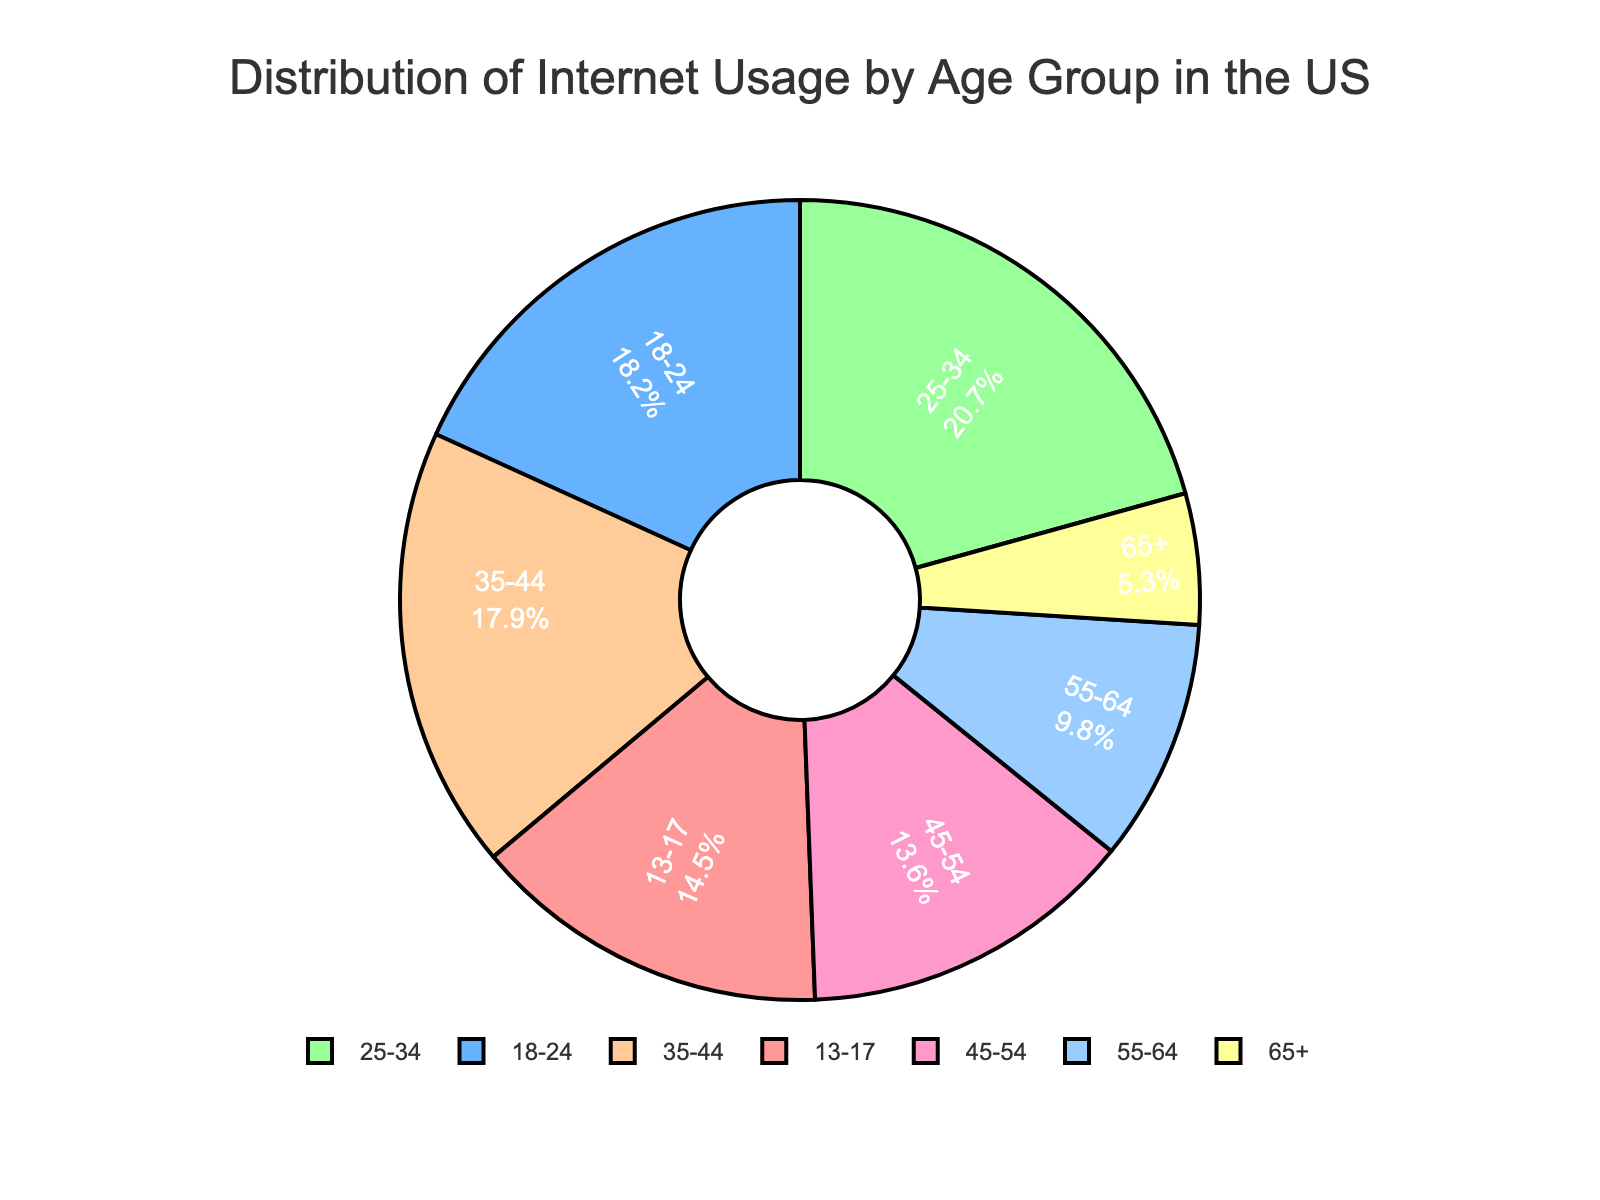What percentage of internet usage is by people aged 18-24? The percentage of internet usage for the 18-24 age group is given directly in the chart.
Answer: 18.2% Compare the internet usage between the 25-34 and 35-44 age groups. Which is higher and by how much? The chart shows that the 25-34 age group accounts for 20.7% of internet usage, and the 35-44 age group accounts for 17.9%. Subtracting these values gives the difference.
Answer: 25-34 by 2.8% What is the combined percentage of internet usage for the age groups 18-24 and 25-34? Adding the percentages for the 18-24 and 25-34 age groups (which are 18.2% and 20.7%, respectively), we get 18.2 + 20.7.
Answer: 38.9% Which age group has the smallest percentage of internet usage? The chart shows the percentage for each age group; the smallest percentage is for the 65+ age group.
Answer: 65+ What is the cumulative percentage of internet usage for all age groups under 35? Adding the percentages for the 13-17, 18-24, and 25-34 age groups: 14.5% + 18.2% + 20.7%.
Answer: 53.4% What is the difference in internet usage between the age groups 45-54 and 55-64? The chart shows the percentages for the 45-54 and 55-64 age groups, which are 13.6% and 9.8%. Subtracting these values gives the difference.
Answer: 3.8% Which age group has the second-highest internet usage percentage? According to the chart, the 25-34 age group has the highest percentage, and the 18-24 age group has the second-highest percentage.
Answer: 18-24 What percentage of internet usage is contributed by people aged 45 and older? Adding the percentages for the 45-54, 55-64, and 65+ age groups: 13.6% + 9.8% + 5.3%.
Answer: 28.7% What is the average percentage of internet usage for the age groups above 35? Adding the percentages for the 35-44, 45-54, 55-64, and 65+ age groups and then dividing by the number of age groups: (17.9 + 13.6 + 9.8 + 5.3) / 4.
Answer: 11.65% Which segment of the pie chart is colored red and what does it represent? The segment that is red represents the age group 13-17, as each color corresponds to a different age group.
Answer: 13-17 